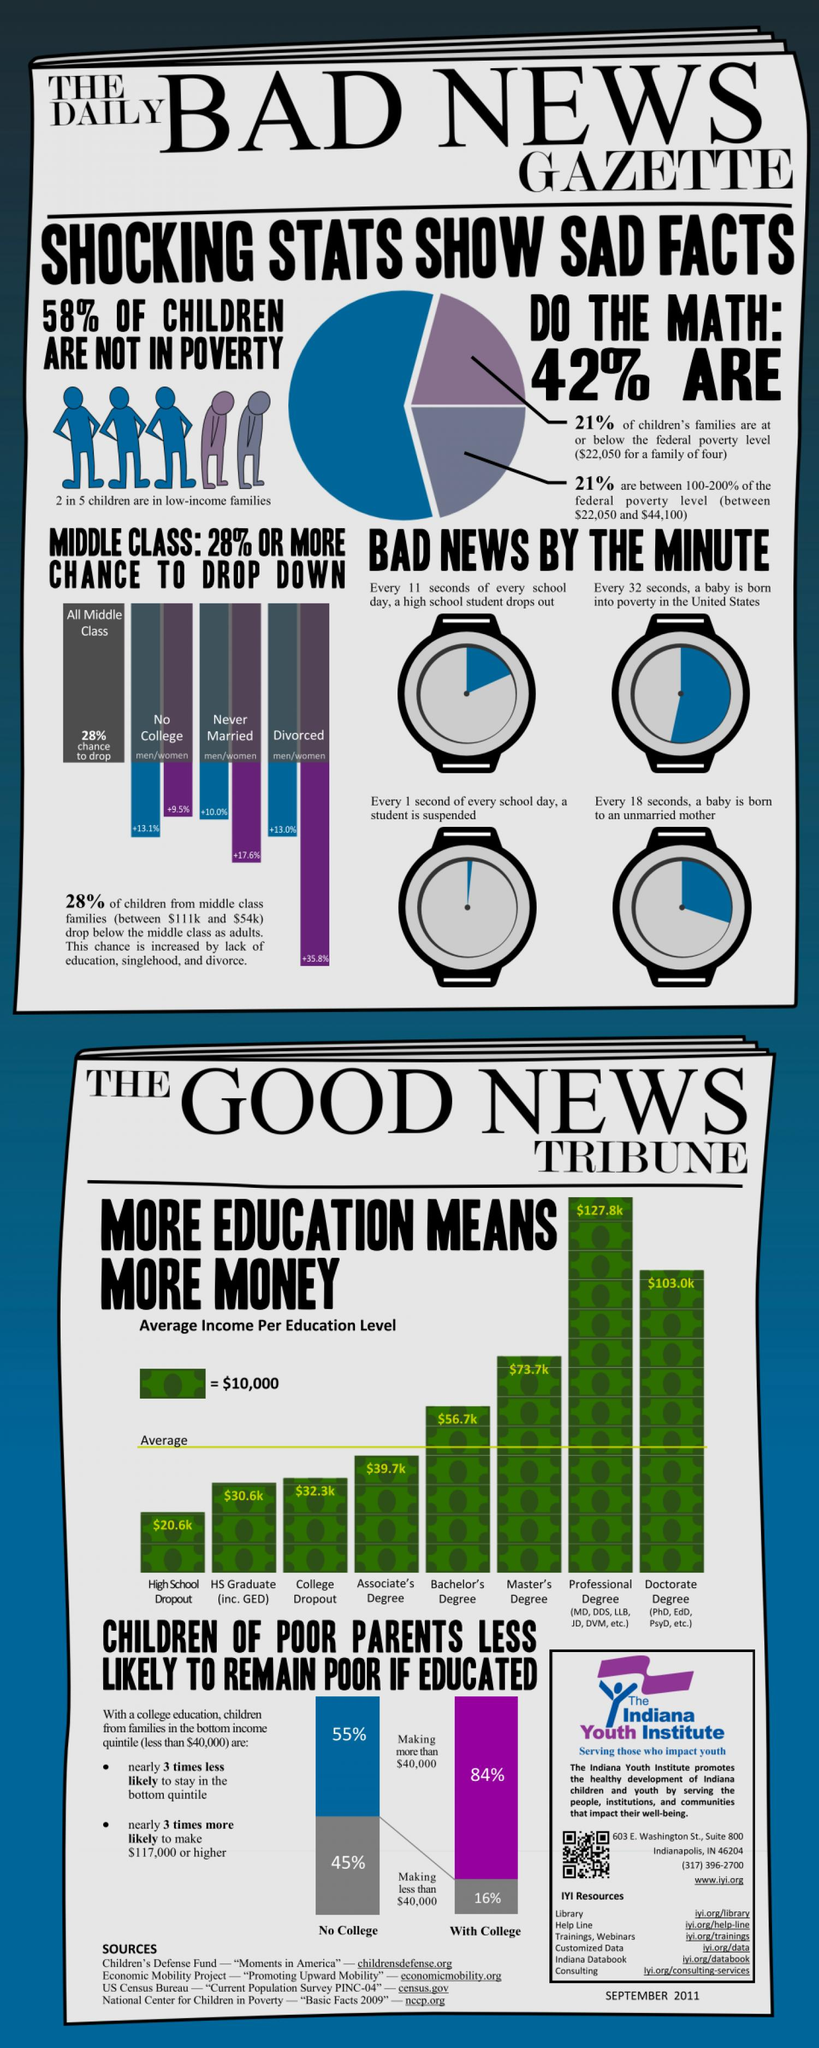Outline some significant characteristics in this image. According to a study, 16% of individuals with a college degree are more likely to earn an income below $40,000. According to the given information, divorced women have a higher chance of dropping into poverty compared to uneducated women, unmarried women, and women without a divorce history. According to a recent study, the highest percentage of men who have dropped into poverty is 13.1%. In just one minute, a child is suspended from school due to poverty every second, every 18 seconds, every 32 seconds, or every 11 seconds. The difference in income between a person with a professional degree and a person with a master's degree is approximately $54,100. 